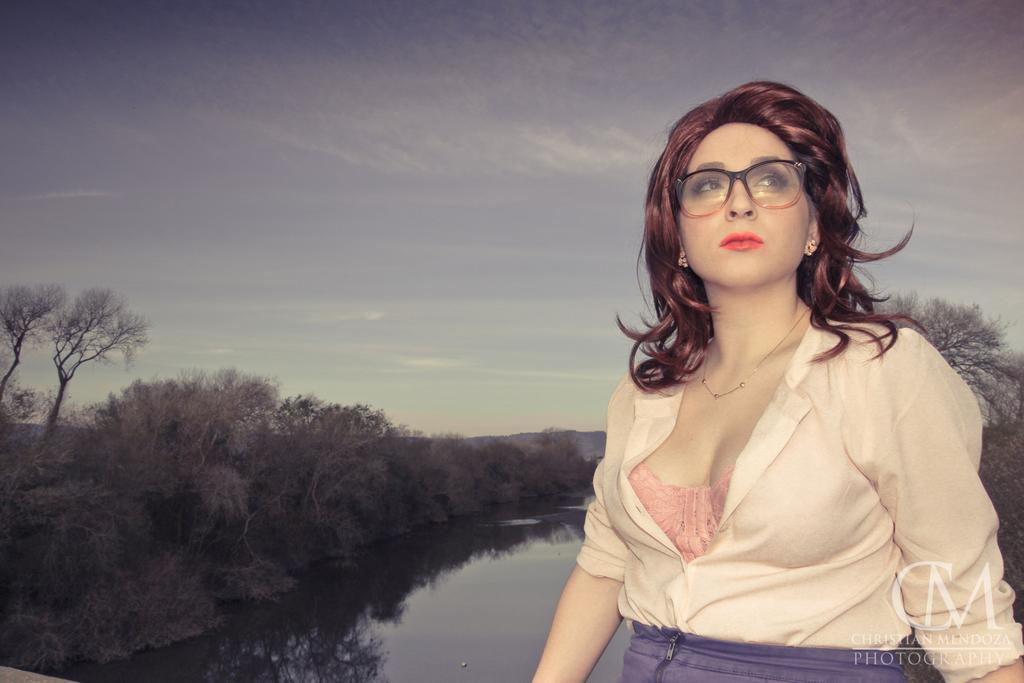Can you describe this image briefly? In the foreground of the picture there is a woman, she is wearing goggles. There is a canal in the center of the picture. On the left there are trees. On the right there are trees. Sky is cloudy. 